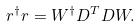Convert formula to latex. <formula><loc_0><loc_0><loc_500><loc_500>r ^ { \dagger } r = W ^ { \dagger } D ^ { T } D W .</formula> 